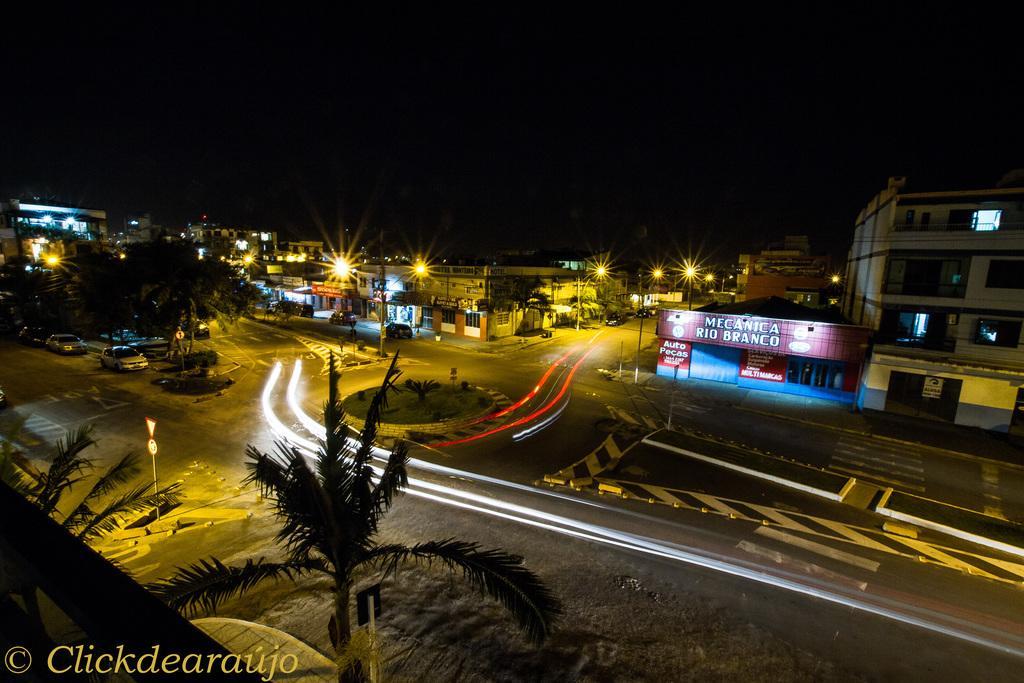Could you give a brief overview of what you see in this image? In this image, I can see the buildings, lights, trees and there are vehicles on the roads. There is a dark background. At the bottom left side of the image, I can see a watermark. 